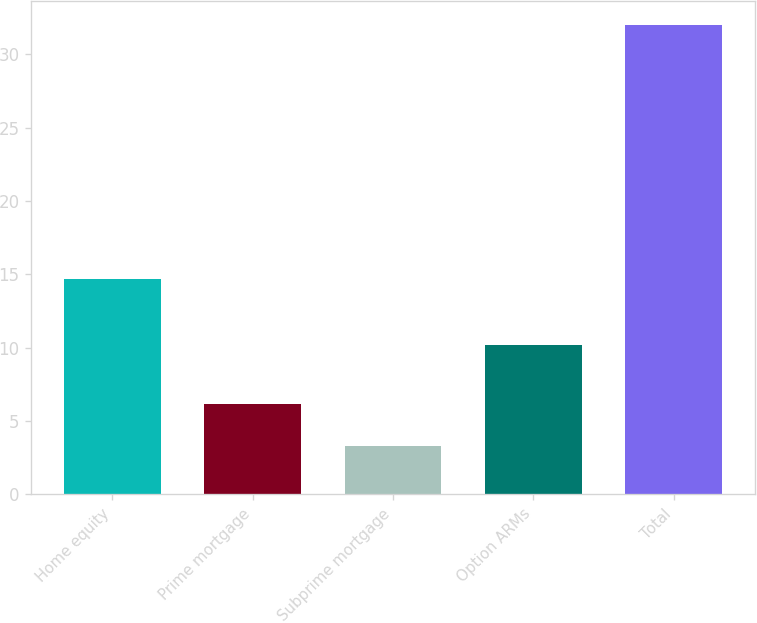Convert chart. <chart><loc_0><loc_0><loc_500><loc_500><bar_chart><fcel>Home equity<fcel>Prime mortgage<fcel>Subprime mortgage<fcel>Option ARMs<fcel>Total<nl><fcel>14.7<fcel>6.17<fcel>3.3<fcel>10.2<fcel>32<nl></chart> 